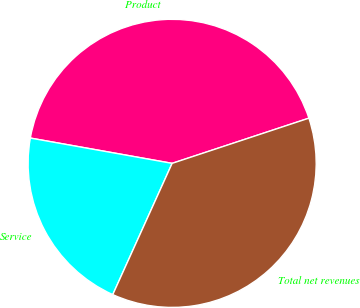<chart> <loc_0><loc_0><loc_500><loc_500><pie_chart><fcel>Product<fcel>Service<fcel>Total net revenues<nl><fcel>42.11%<fcel>21.05%<fcel>36.84%<nl></chart> 